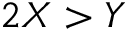Convert formula to latex. <formula><loc_0><loc_0><loc_500><loc_500>2 X > Y</formula> 